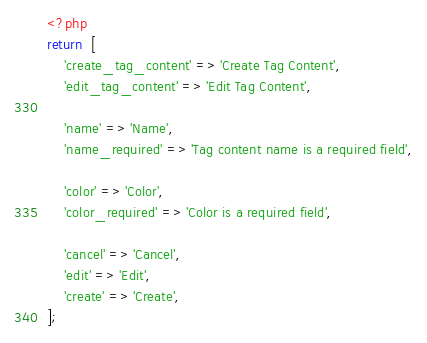Convert code to text. <code><loc_0><loc_0><loc_500><loc_500><_PHP_><?php
return  [
    'create_tag_content' => 'Create Tag Content',
    'edit_tag_content' => 'Edit Tag Content',

    'name' => 'Name',
    'name_required' => 'Tag content name is a required field',

    'color' => 'Color',
    'color_required' => 'Color is a required field',

    'cancel' => 'Cancel',
    'edit' => 'Edit',
    'create' => 'Create',
];</code> 